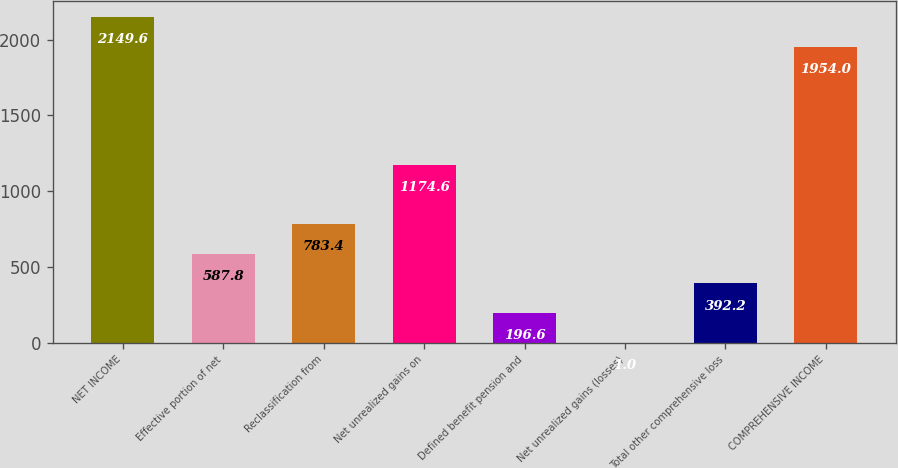Convert chart to OTSL. <chart><loc_0><loc_0><loc_500><loc_500><bar_chart><fcel>NET INCOME<fcel>Effective portion of net<fcel>Reclassification from<fcel>Net unrealized gains on<fcel>Defined benefit pension and<fcel>Net unrealized gains (losses)<fcel>Total other comprehensive loss<fcel>COMPREHENSIVE INCOME<nl><fcel>2149.6<fcel>587.8<fcel>783.4<fcel>1174.6<fcel>196.6<fcel>1<fcel>392.2<fcel>1954<nl></chart> 